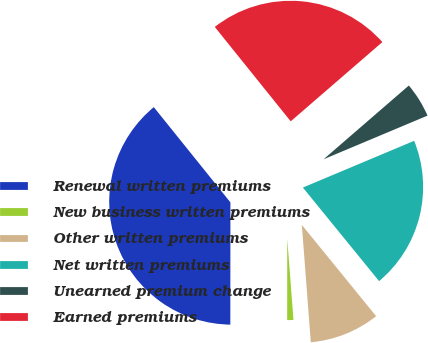Convert chart to OTSL. <chart><loc_0><loc_0><loc_500><loc_500><pie_chart><fcel>Renewal written premiums<fcel>New business written premiums<fcel>Other written premiums<fcel>Net written premiums<fcel>Unearned premium change<fcel>Earned premiums<nl><fcel>39.2%<fcel>1.23%<fcel>9.66%<fcel>20.45%<fcel>5.02%<fcel>24.43%<nl></chart> 